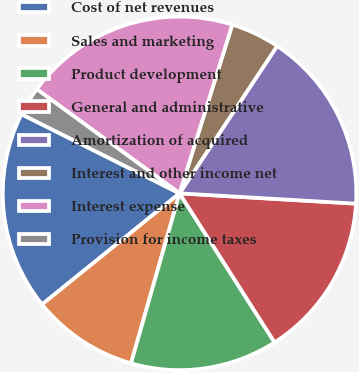<chart> <loc_0><loc_0><loc_500><loc_500><pie_chart><fcel>Cost of net revenues<fcel>Sales and marketing<fcel>Product development<fcel>General and administrative<fcel>Amortization of acquired<fcel>Interest and other income net<fcel>Interest expense<fcel>Provision for income taxes<nl><fcel>18.21%<fcel>9.76%<fcel>13.46%<fcel>15.04%<fcel>16.62%<fcel>4.49%<fcel>19.79%<fcel>2.64%<nl></chart> 